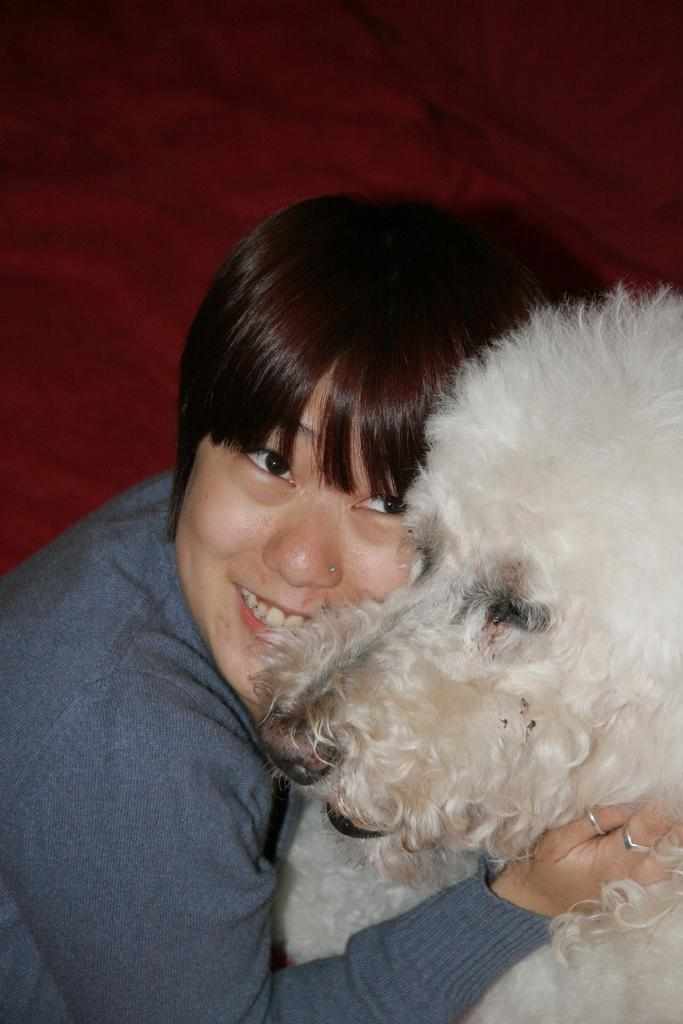What is the main subject of the image? The main subject of the image is a woman. What is the woman doing in the image? The woman is smiling in the image. What is the woman holding in her arms? The woman is holding a pet in her arms. How many rabbits can be seen hopping in the background of the image? There are no rabbits visible in the image. What season is depicted in the image? The provided facts do not mention any specific season. 